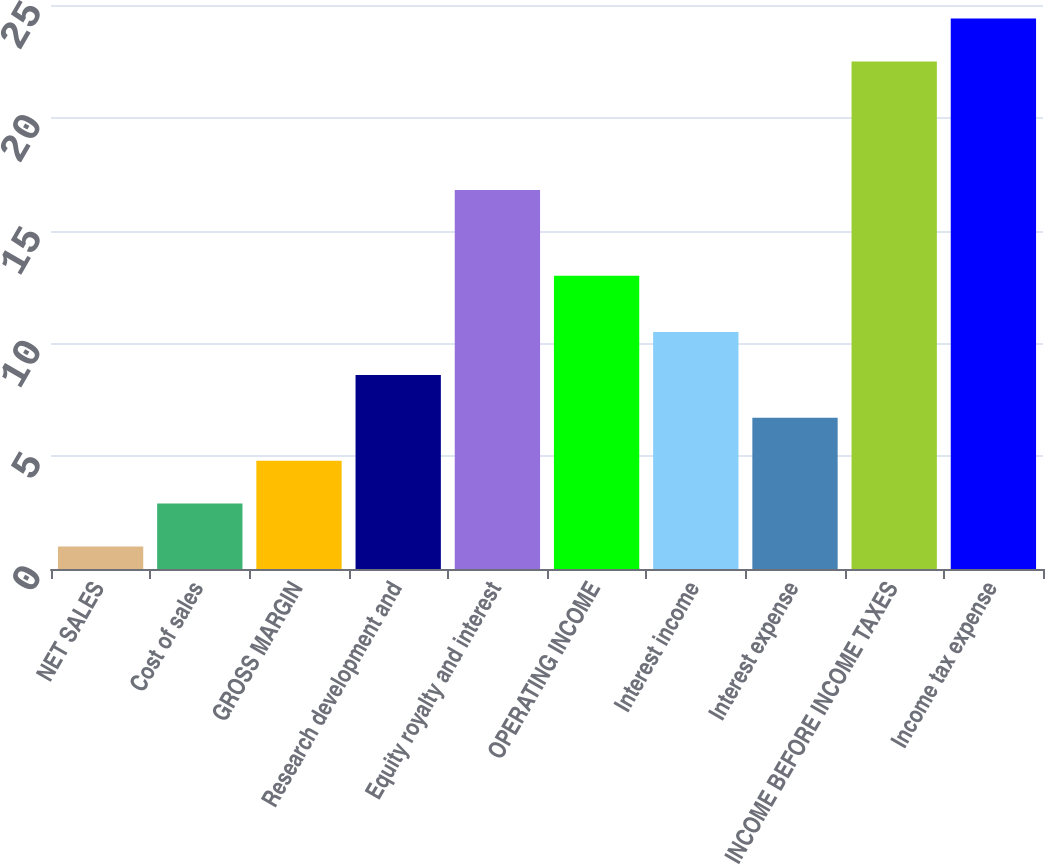<chart> <loc_0><loc_0><loc_500><loc_500><bar_chart><fcel>NET SALES<fcel>Cost of sales<fcel>GROSS MARGIN<fcel>Research development and<fcel>Equity royalty and interest<fcel>OPERATING INCOME<fcel>Interest income<fcel>Interest expense<fcel>INCOME BEFORE INCOME TAXES<fcel>Income tax expense<nl><fcel>1<fcel>2.9<fcel>4.8<fcel>8.6<fcel>16.8<fcel>13<fcel>10.5<fcel>6.7<fcel>22.5<fcel>24.4<nl></chart> 